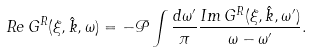Convert formula to latex. <formula><loc_0><loc_0><loc_500><loc_500>R e \, G ^ { R } ( \xi , \hat { k } , \omega ) = - \mathcal { P } \int \frac { d \omega ^ { \prime } } { \pi } \frac { I m \, G ^ { R } ( \xi , \hat { k } , \omega ^ { \prime } ) } { \omega - \omega ^ { \prime } } .</formula> 